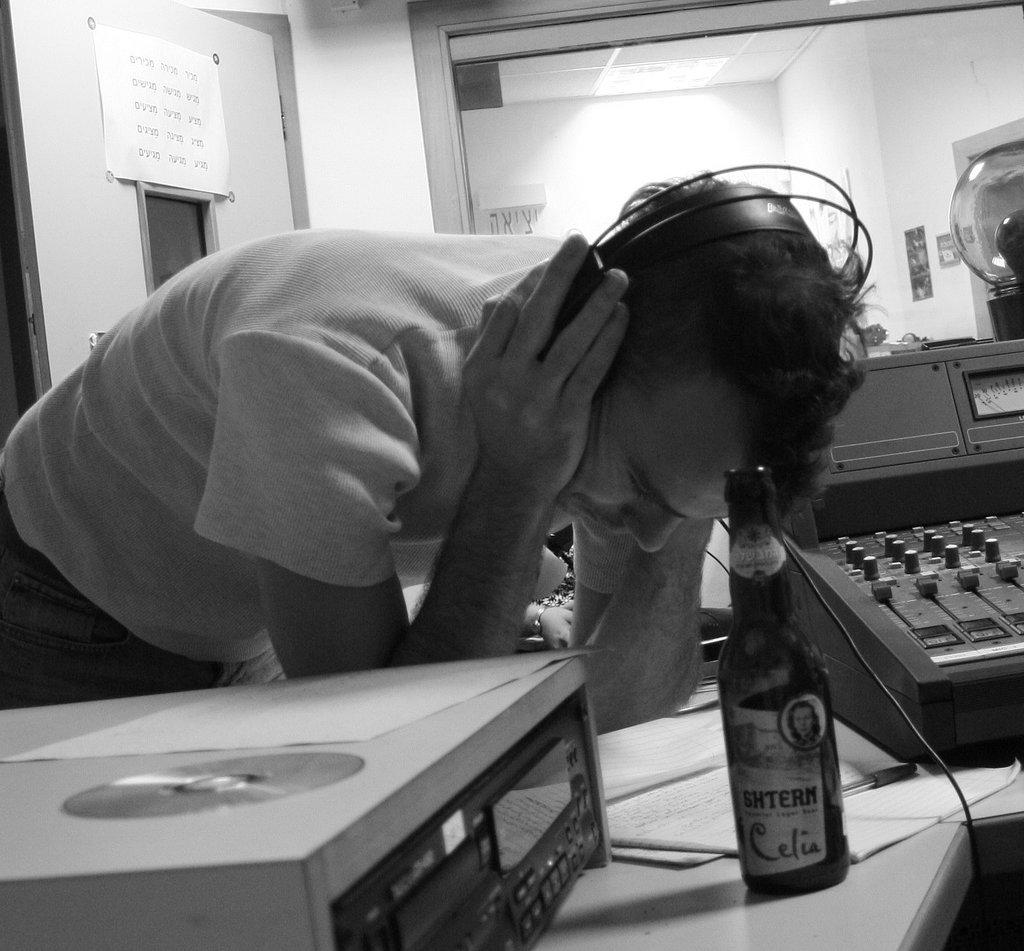Who or what is present in the image? There is a person in the image. What objects can be seen on the desk in the image? There are devices on a desk in the image. What type of container is visible in the image? There is a glass bottle in the image. What can be seen behind the person or objects in the image? There is a wall visible in the background of the image. What type of apparel is the person wearing in the image? The provided facts do not mention any apparel worn by the person in the image. 